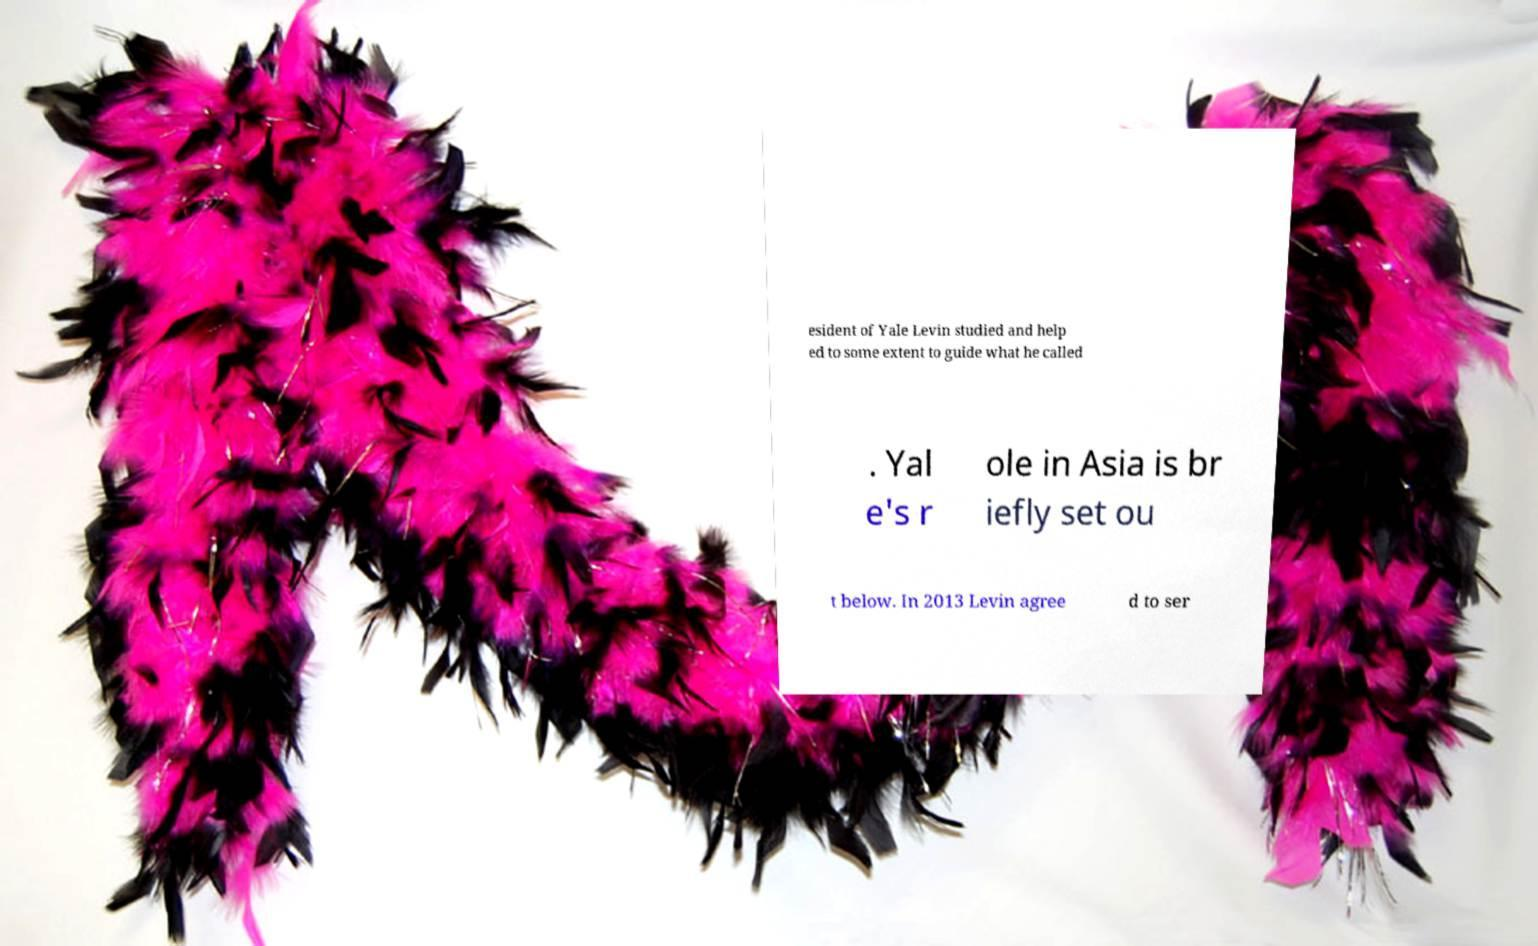For documentation purposes, I need the text within this image transcribed. Could you provide that? esident of Yale Levin studied and help ed to some extent to guide what he called . Yal e's r ole in Asia is br iefly set ou t below. In 2013 Levin agree d to ser 